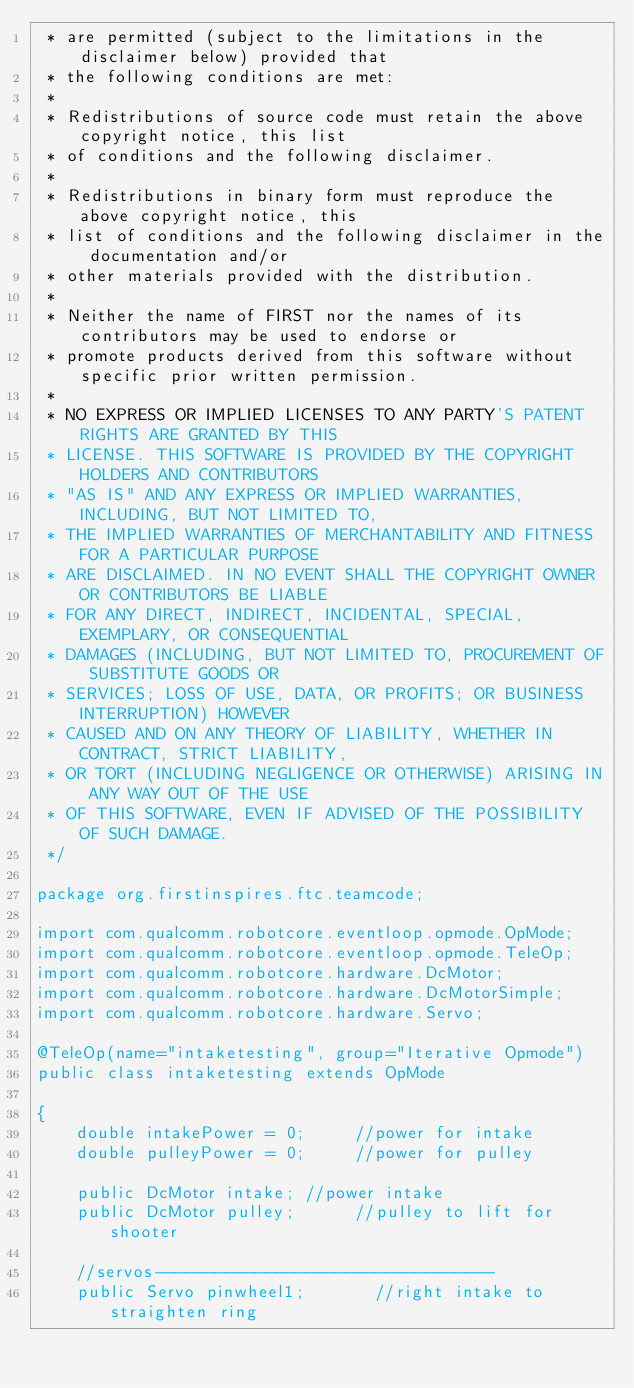<code> <loc_0><loc_0><loc_500><loc_500><_Java_> * are permitted (subject to the limitations in the disclaimer below) provided that
 * the following conditions are met:
 *
 * Redistributions of source code must retain the above copyright notice, this list
 * of conditions and the following disclaimer.
 *
 * Redistributions in binary form must reproduce the above copyright notice, this
 * list of conditions and the following disclaimer in the documentation and/or
 * other materials provided with the distribution.
 *
 * Neither the name of FIRST nor the names of its contributors may be used to endorse or
 * promote products derived from this software without specific prior written permission.
 *
 * NO EXPRESS OR IMPLIED LICENSES TO ANY PARTY'S PATENT RIGHTS ARE GRANTED BY THIS
 * LICENSE. THIS SOFTWARE IS PROVIDED BY THE COPYRIGHT HOLDERS AND CONTRIBUTORS
 * "AS IS" AND ANY EXPRESS OR IMPLIED WARRANTIES, INCLUDING, BUT NOT LIMITED TO,
 * THE IMPLIED WARRANTIES OF MERCHANTABILITY AND FITNESS FOR A PARTICULAR PURPOSE
 * ARE DISCLAIMED. IN NO EVENT SHALL THE COPYRIGHT OWNER OR CONTRIBUTORS BE LIABLE
 * FOR ANY DIRECT, INDIRECT, INCIDENTAL, SPECIAL, EXEMPLARY, OR CONSEQUENTIAL
 * DAMAGES (INCLUDING, BUT NOT LIMITED TO, PROCUREMENT OF SUBSTITUTE GOODS OR
 * SERVICES; LOSS OF USE, DATA, OR PROFITS; OR BUSINESS INTERRUPTION) HOWEVER
 * CAUSED AND ON ANY THEORY OF LIABILITY, WHETHER IN CONTRACT, STRICT LIABILITY,
 * OR TORT (INCLUDING NEGLIGENCE OR OTHERWISE) ARISING IN ANY WAY OUT OF THE USE
 * OF THIS SOFTWARE, EVEN IF ADVISED OF THE POSSIBILITY OF SUCH DAMAGE.
 */

package org.firstinspires.ftc.teamcode;

import com.qualcomm.robotcore.eventloop.opmode.OpMode;
import com.qualcomm.robotcore.eventloop.opmode.TeleOp;
import com.qualcomm.robotcore.hardware.DcMotor;
import com.qualcomm.robotcore.hardware.DcMotorSimple;
import com.qualcomm.robotcore.hardware.Servo;

@TeleOp(name="intaketesting", group="Iterative Opmode")
public class intaketesting extends OpMode

{
    double intakePower = 0;     //power for intake
    double pulleyPower = 0;     //power for pulley

    public DcMotor intake; //power intake
    public DcMotor pulley;      //pulley to lift for shooter

    //servos----------------------------------
    public Servo pinwheel1;       //right intake to straighten ring</code> 